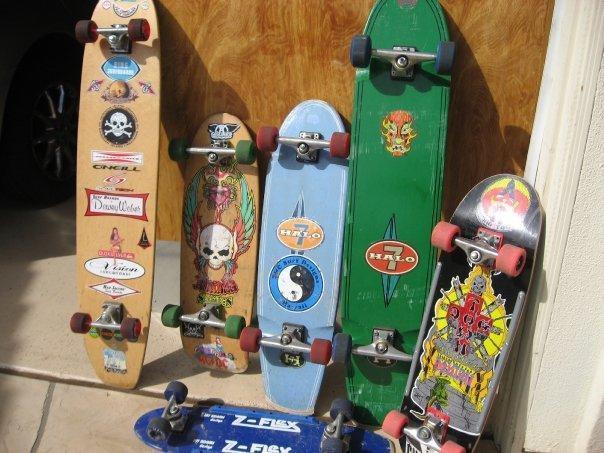How many skateboards are laying down?
Give a very brief answer. 1. How many boards are shown?
Give a very brief answer. 6. How many skateboards are there?
Give a very brief answer. 6. How many green bikes are in the picture?
Give a very brief answer. 0. 